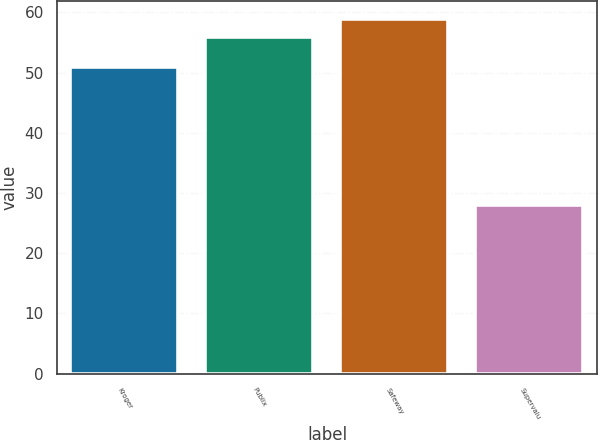Convert chart to OTSL. <chart><loc_0><loc_0><loc_500><loc_500><bar_chart><fcel>Kroger<fcel>Publix<fcel>Safeway<fcel>Supervalu<nl><fcel>51<fcel>56<fcel>58.9<fcel>28<nl></chart> 